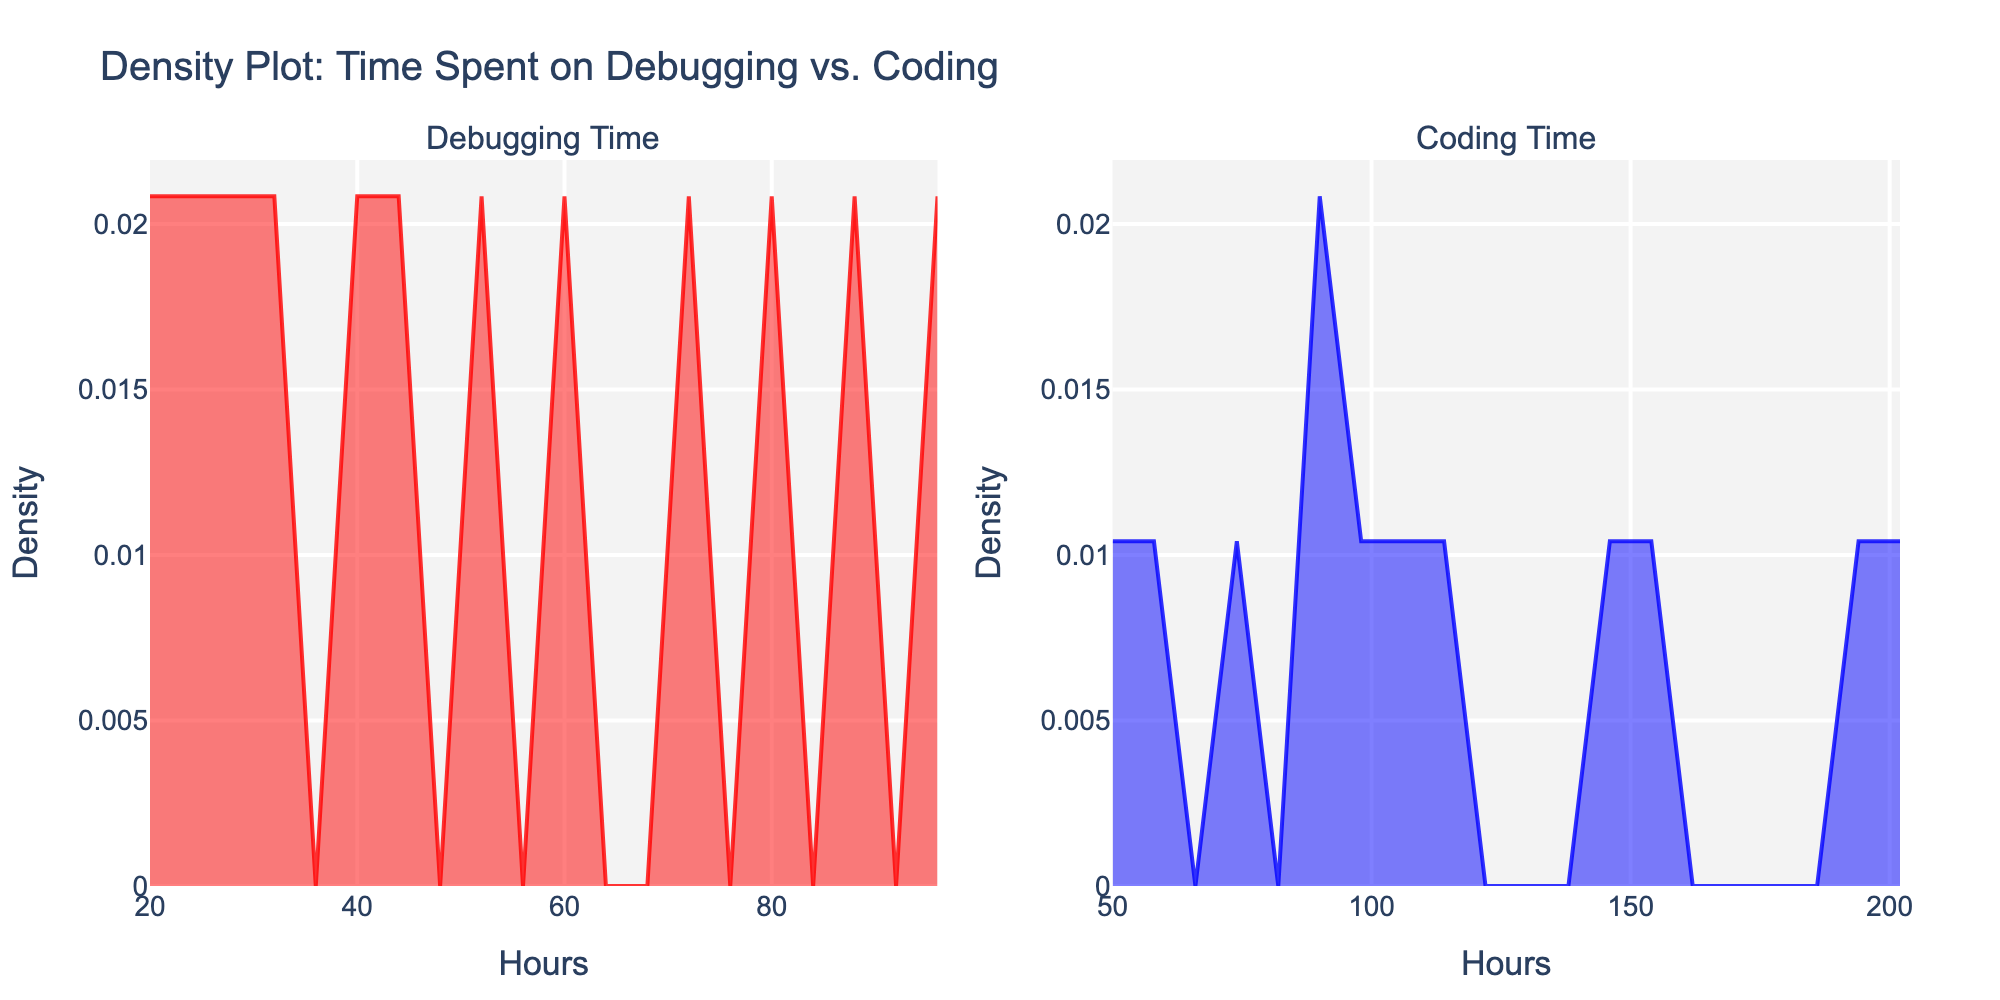What is the title of the figure? The title is displayed at the top of the figure. It summarizes the content of the plot.
Answer: Density Plot: Time Spent on Debugging vs. Coding Which subplot represents the density of time spent on debugging? The subplot title will indicate which subplot is associated with debugging time.
Answer: The left subplot What is the x-axis label for both subplots? The x-axis labels appear below the horizontal axis on both subplots, indicating what the x-values represent.
Answer: Hours Which subplot has a higher density peak? By observing the height of the peaks in both subplots, we can determine which one is higher.
Answer: The left subplot (Debugging Time) What are the color schemes used for the debugging and coding density plots? The color of the lines and filled areas in each subplot indicates the color scheme used.
Answer: Debugging is red, coding is blue Approximately, what is the highest density value in the debugging subplot? Identify the peak of the density curve in the debugging subplot to estimate the highest density value.
Answer: Around 0.04 How do the densities of time spent on debugging and coding compare overall? Compare the overall spread and height of the density curves in both subplots to assess their relative densities.
Answer: Coding generally has higher density values and a broader spread What is the range of hours for which the density of coding time is significant? Observe the range along the x-axis in the coding subplot where the density values are noticeably above zero.
Answer: From 50 to 200 hours If you sum the highest density values from both subplots, what is the result? Identify the peak density values in both subplots, then compute their sum.
Answer: Around 0.075 Is there more variability in time spent on debugging or coding? The spread and shape of the density curves indicate variability. A wider spread suggests more variability.
Answer: Coding 